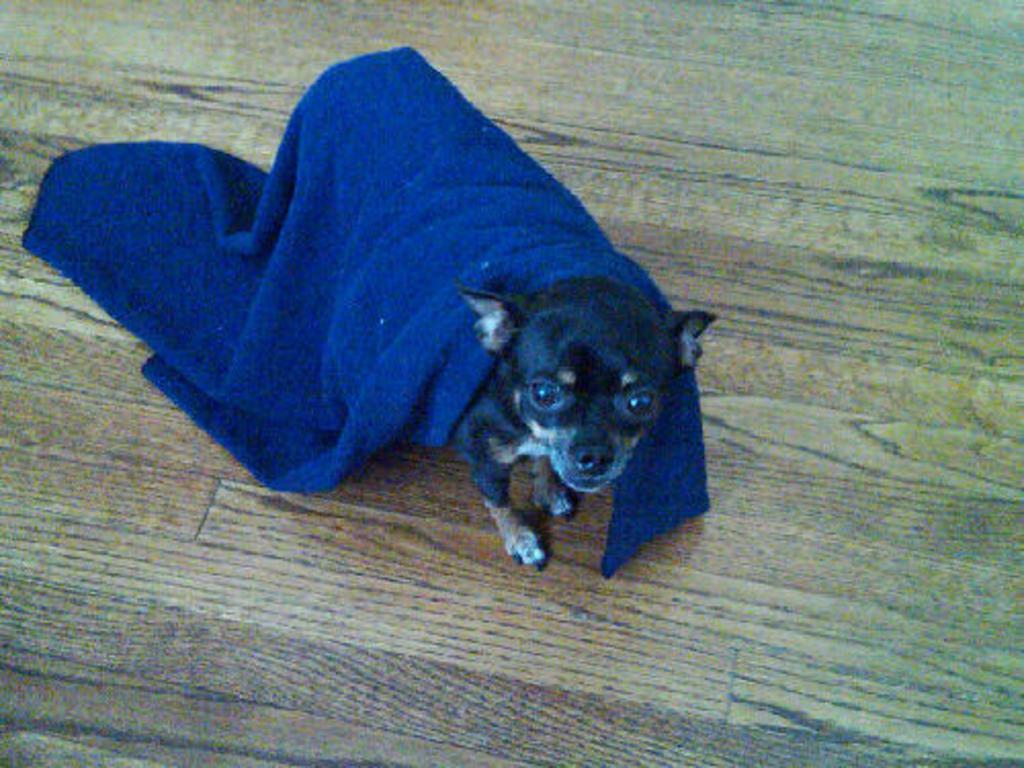What type of animal is in the image? There is a dog in the image. What is covering the dog? The dog has a blue cloth on it. What material is the floor made of? The floor is made of wood. What type of butter is being used by the dog in the image? There is no butter present in the image; it features a dog with a blue cloth on it and a wooden floor. Can you tell me how many donkeys are in the image? There are no donkeys present in the image; it features a dog with a blue cloth on it and a wooden floor. 